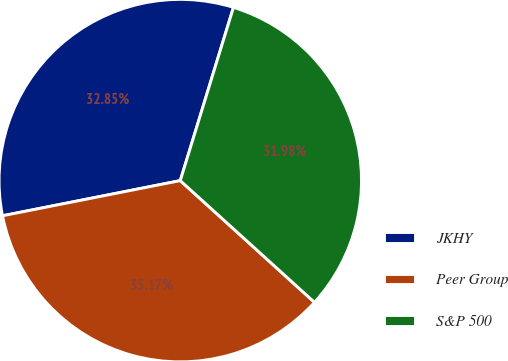Convert chart to OTSL. <chart><loc_0><loc_0><loc_500><loc_500><pie_chart><fcel>JKHY<fcel>Peer Group<fcel>S&P 500<nl><fcel>32.85%<fcel>35.17%<fcel>31.98%<nl></chart> 